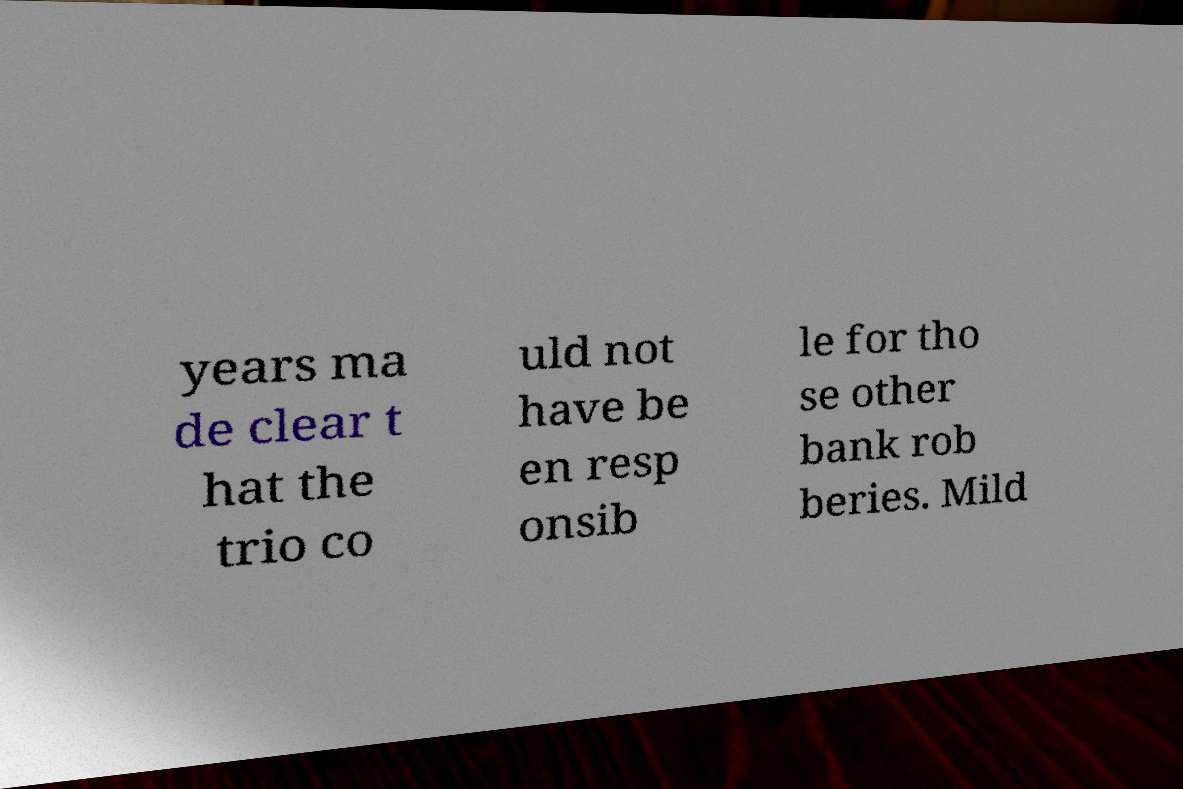Please identify and transcribe the text found in this image. years ma de clear t hat the trio co uld not have be en resp onsib le for tho se other bank rob beries. Mild 